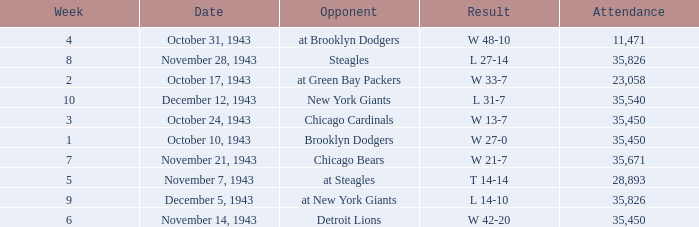How many attendances have w 48-10 as the result? 11471.0. Can you give me this table as a dict? {'header': ['Week', 'Date', 'Opponent', 'Result', 'Attendance'], 'rows': [['4', 'October 31, 1943', 'at Brooklyn Dodgers', 'W 48-10', '11,471'], ['8', 'November 28, 1943', 'Steagles', 'L 27-14', '35,826'], ['2', 'October 17, 1943', 'at Green Bay Packers', 'W 33-7', '23,058'], ['10', 'December 12, 1943', 'New York Giants', 'L 31-7', '35,540'], ['3', 'October 24, 1943', 'Chicago Cardinals', 'W 13-7', '35,450'], ['1', 'October 10, 1943', 'Brooklyn Dodgers', 'W 27-0', '35,450'], ['7', 'November 21, 1943', 'Chicago Bears', 'W 21-7', '35,671'], ['5', 'November 7, 1943', 'at Steagles', 'T 14-14', '28,893'], ['9', 'December 5, 1943', 'at New York Giants', 'L 14-10', '35,826'], ['6', 'November 14, 1943', 'Detroit Lions', 'W 42-20', '35,450']]} 